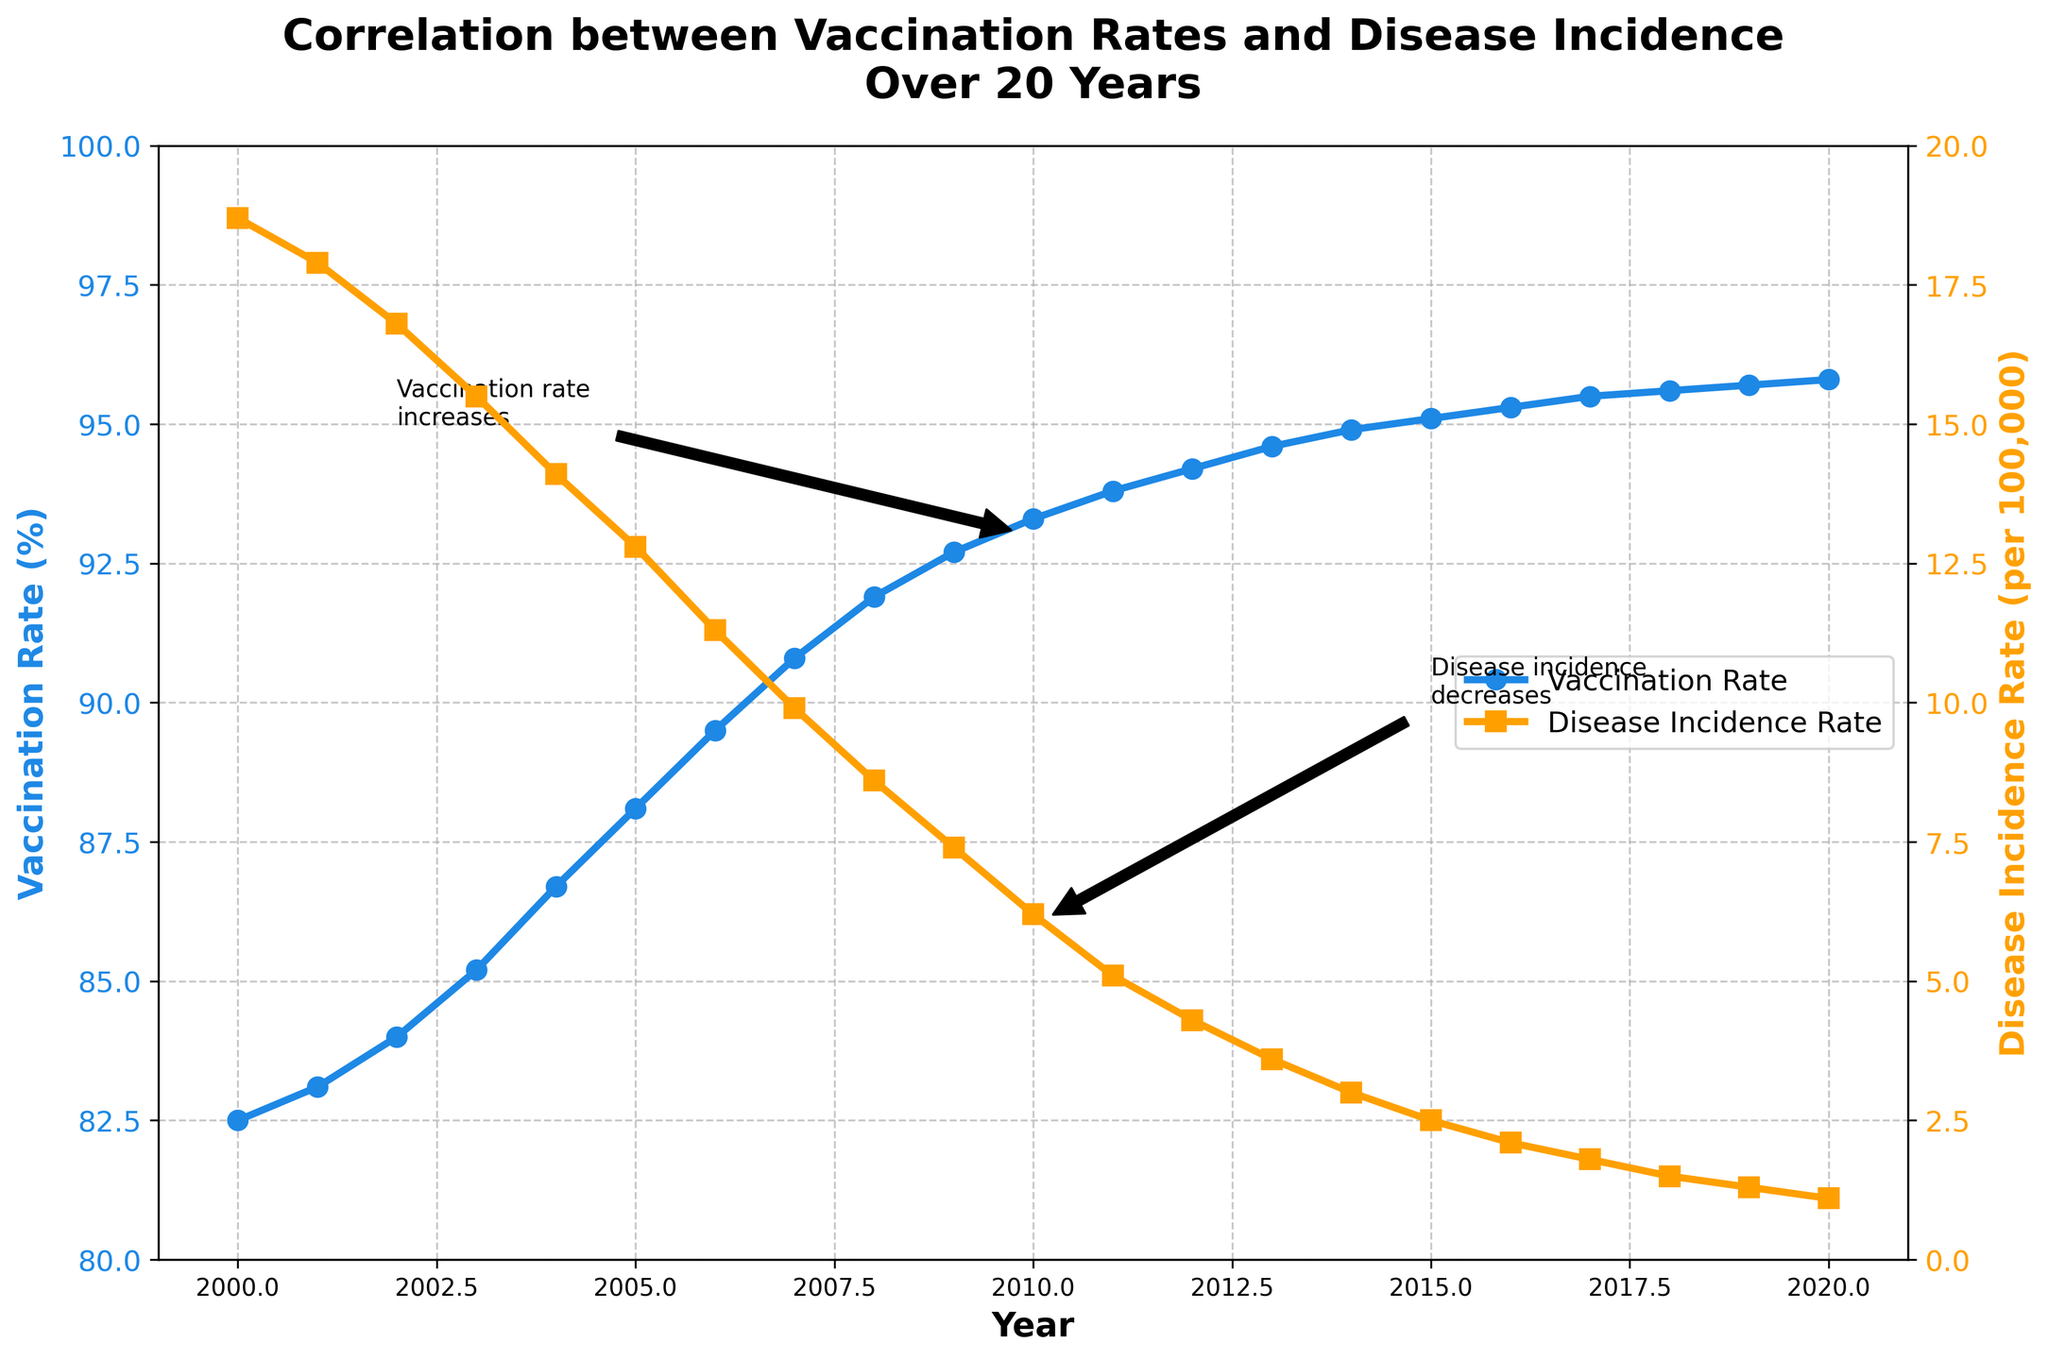what are the differences in vaccination rates from the earliest to the latest year displayed in the chart? Look at the vaccination rates in 2000 and 2020. Subtract the earlier year's rate from the later year's rate. The rates are 95.8% in 2020 and 82.5% in 2000, resulting in 95.8 - 82.5 = 13.3%.
Answer: 13.3% Has there been a year when the disease incidence rate dropped significantly compared to the previous year? Compare the disease incidence rates year by year. Notably, 2007 to 2008 sees a drop from 9.9 to 8.6, another year significant comparison is 2005 to 2006, from 12.8 to 11.3, noticing the trend identifies these years with most quick drops.
Answer: 2007 to 2008 What is the trend of the vaccination rate over the period 2000 to 2020? Observe the line representing vaccination rate in the figure. It shows a consistent upward trend from 2000 to 2020.
Answer: Increasing What is the average vaccination rate over the entire period? Sum all the vaccination rates over the years 2000 to 2020 and then divide by the number of years (21). The sum of rates is 1877.4. The average rate is 1877.4 / 21 = 89.4%.
Answer: 89.4% What is the slope of the trend in disease incidence rates between 2010 and 2020? Find the difference in disease incidence rates between 2010 and 2020 (6.2 - 1.1 = 5.1) and divide by the number of years (2020 - 2010 = 10). The slope is 5.1 / 10 = 0.51, showing an average annual decrease of 0.51 per 100,000.
Answer: 0.51 Are there any periods where both vaccination rate and disease incidence rate remained relatively steady? Examine the portions of both lines where neither fluctuates markedly. From 2017 to 2020, both lines show minimal change with the vaccination rate around 95.5% and disease incidence rate decreasing steadily.
Answer: 2017 to 2020 In what year did the vaccination rate first surpass 90%? Locate the first year where the vaccination rate line crosses above the 90% mark. This occurred in 2007 with a rate of 90.8%.
Answer: 2007 How much did the disease incidence rate decrease from 2000 to 2020? Observe the disease incidence rates in 2000 and 2020. Subtract the later year's rate from the earlier year's rate. The rates are 1.1 in 2020 and 18.7 in 2000, resulting in 18.7 - 1.1 = 17.6 per 100,000.
Answer: 17.6 per 100,000 